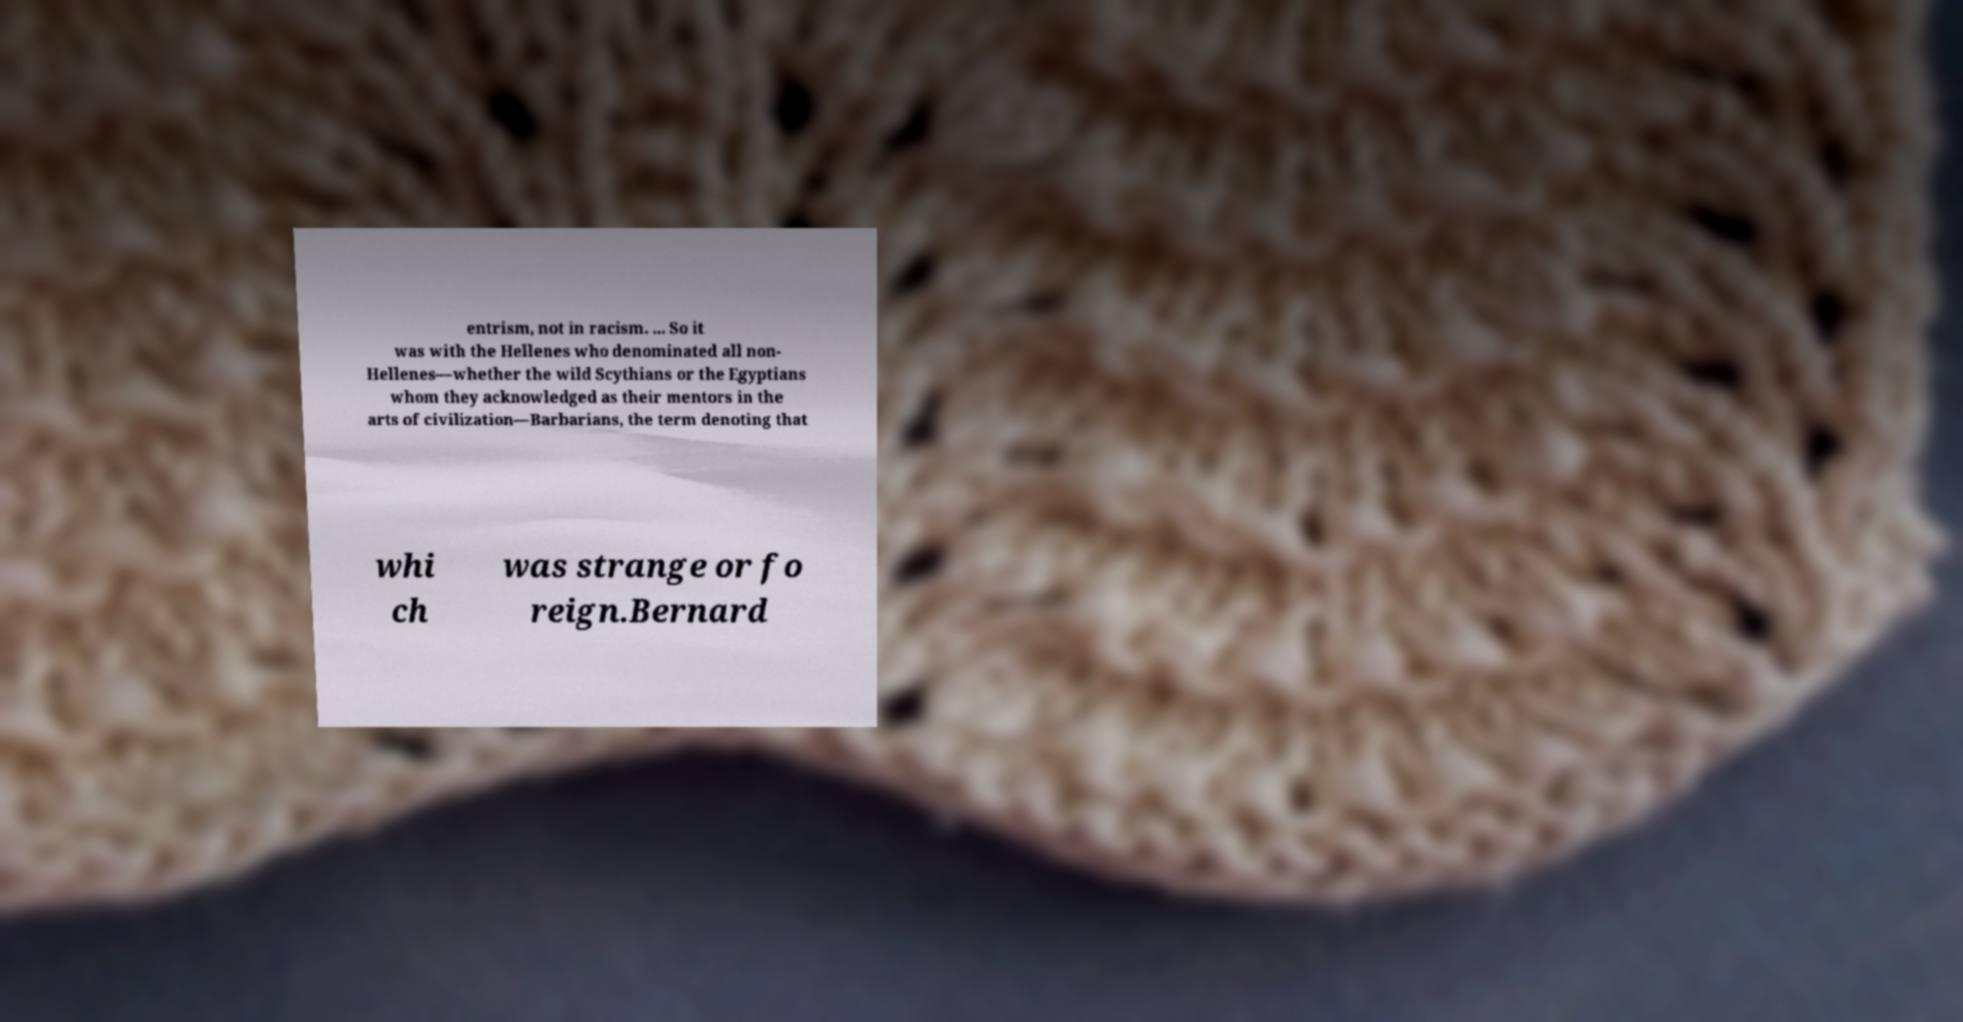What messages or text are displayed in this image? I need them in a readable, typed format. entrism, not in racism. ... So it was with the Hellenes who denominated all non- Hellenes—whether the wild Scythians or the Egyptians whom they acknowledged as their mentors in the arts of civilization—Barbarians, the term denoting that whi ch was strange or fo reign.Bernard 